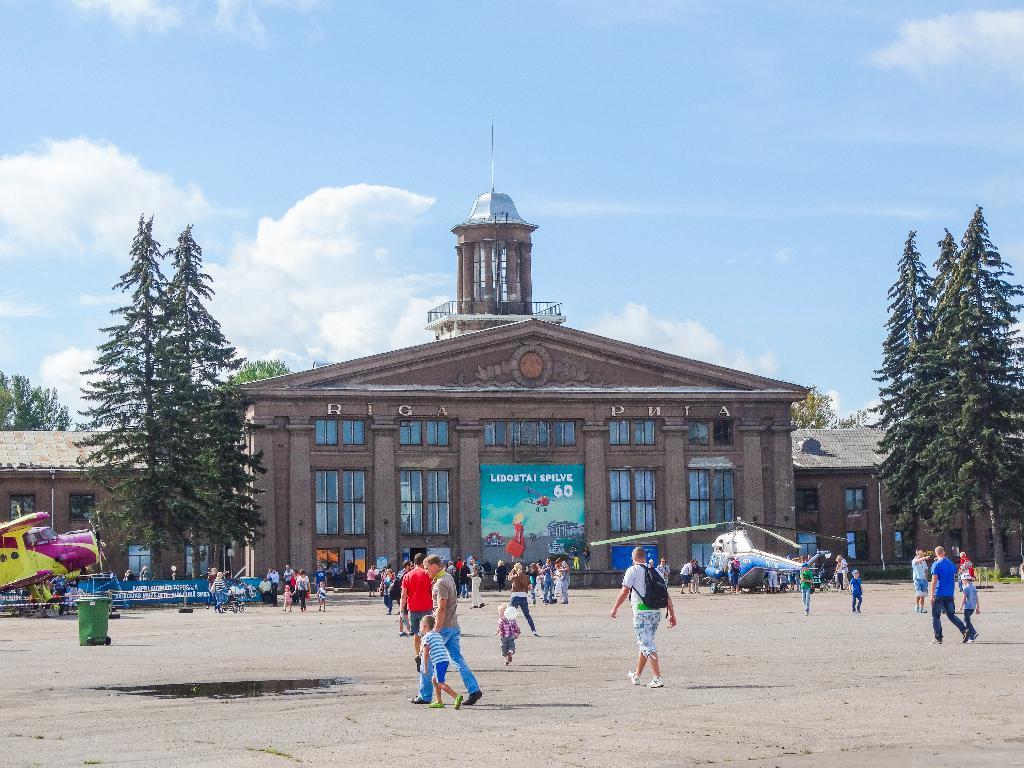Could you give a brief overview of what you see in this image? In this image, we can see few people. Few are standing and walking. Here we can see banners, aircrafts, dustbin, trees, building, hoarding, walls and windows. Background there is a sky. Here we can see railings and pillars. 